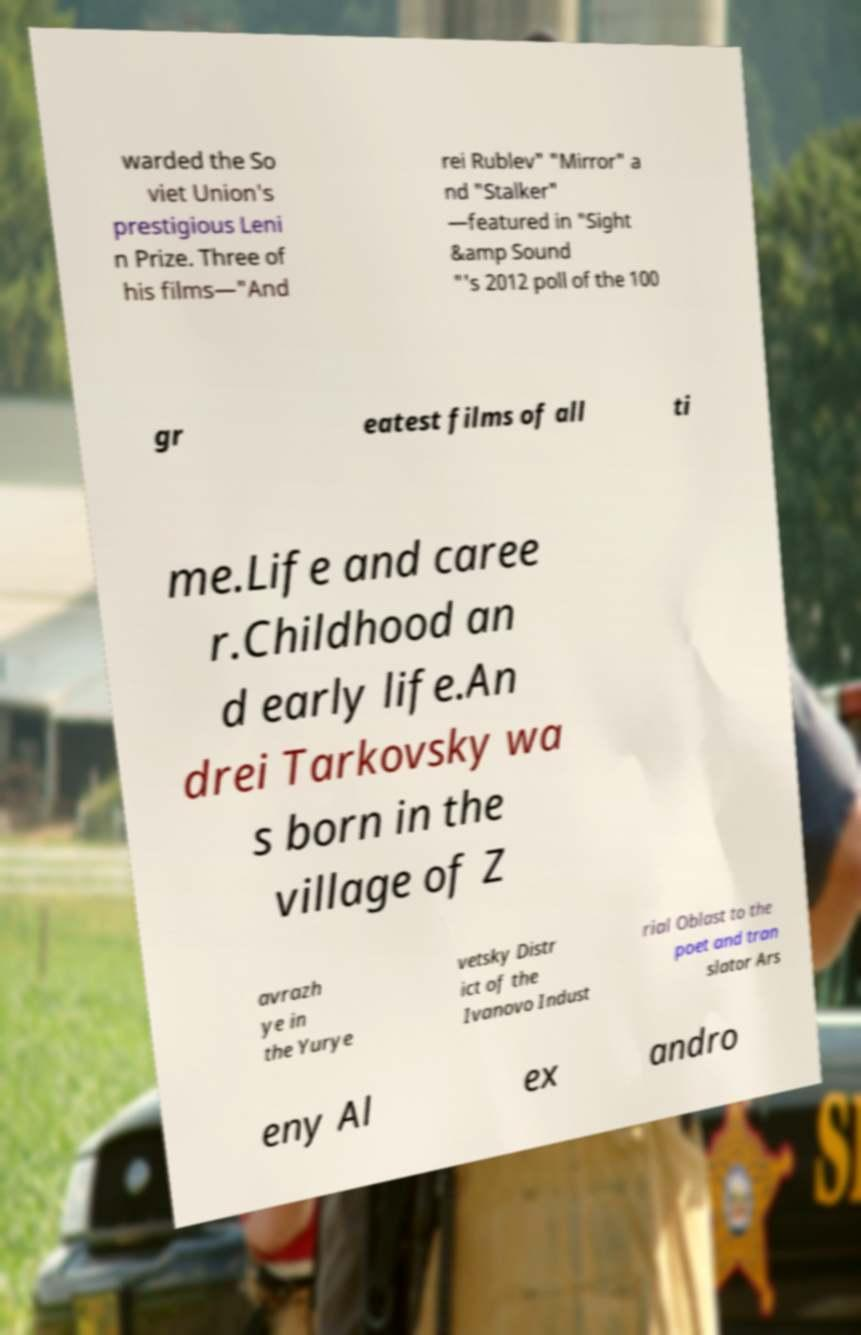There's text embedded in this image that I need extracted. Can you transcribe it verbatim? warded the So viet Union's prestigious Leni n Prize. Three of his films—"And rei Rublev" "Mirror" a nd "Stalker" —featured in "Sight &amp Sound "'s 2012 poll of the 100 gr eatest films of all ti me.Life and caree r.Childhood an d early life.An drei Tarkovsky wa s born in the village of Z avrazh ye in the Yurye vetsky Distr ict of the Ivanovo Indust rial Oblast to the poet and tran slator Ars eny Al ex andro 